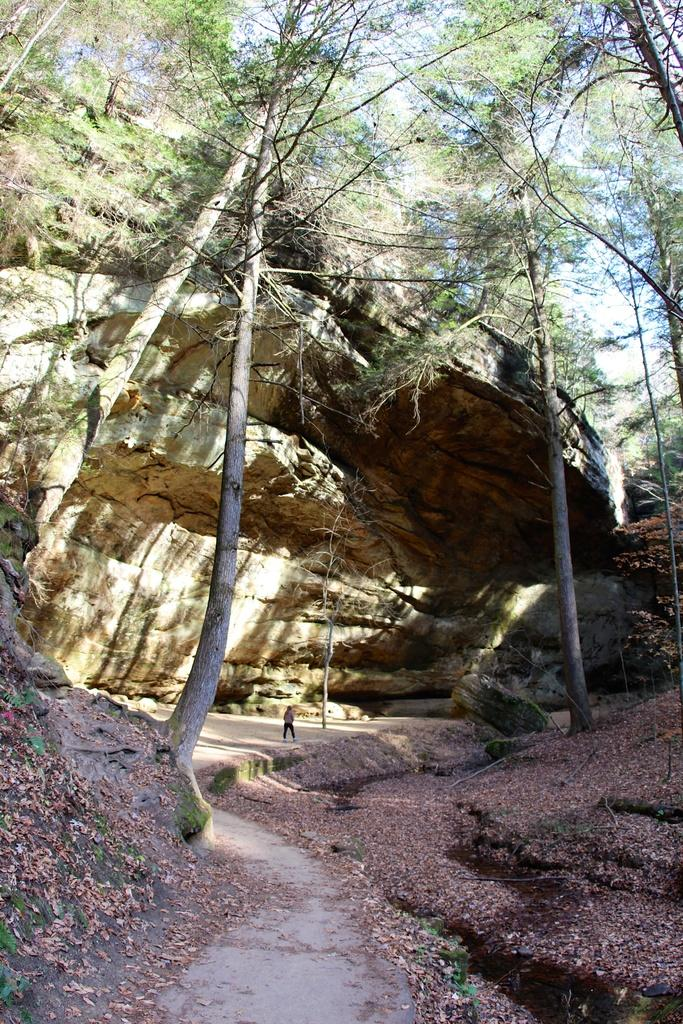What is floating on the water in the image? There are dried leaves on the water in the image. Can you describe the person in the background? There is a person standing in front of a rock in the background. What type of vegetation can be seen in the background? There are many trees visible in the background. What is visible in the sky in the image? The sky is visible in the background. What type of copper can be seen in the image? There is no copper present in the image. 